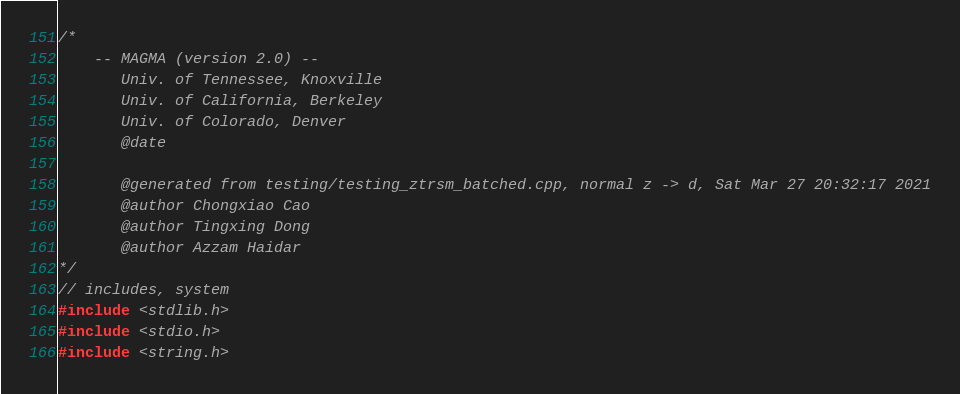<code> <loc_0><loc_0><loc_500><loc_500><_C++_>/*
    -- MAGMA (version 2.0) --
       Univ. of Tennessee, Knoxville
       Univ. of California, Berkeley
       Univ. of Colorado, Denver
       @date

       @generated from testing/testing_ztrsm_batched.cpp, normal z -> d, Sat Mar 27 20:32:17 2021
       @author Chongxiao Cao
       @author Tingxing Dong
       @author Azzam Haidar
*/
// includes, system
#include <stdlib.h>
#include <stdio.h>
#include <string.h></code> 